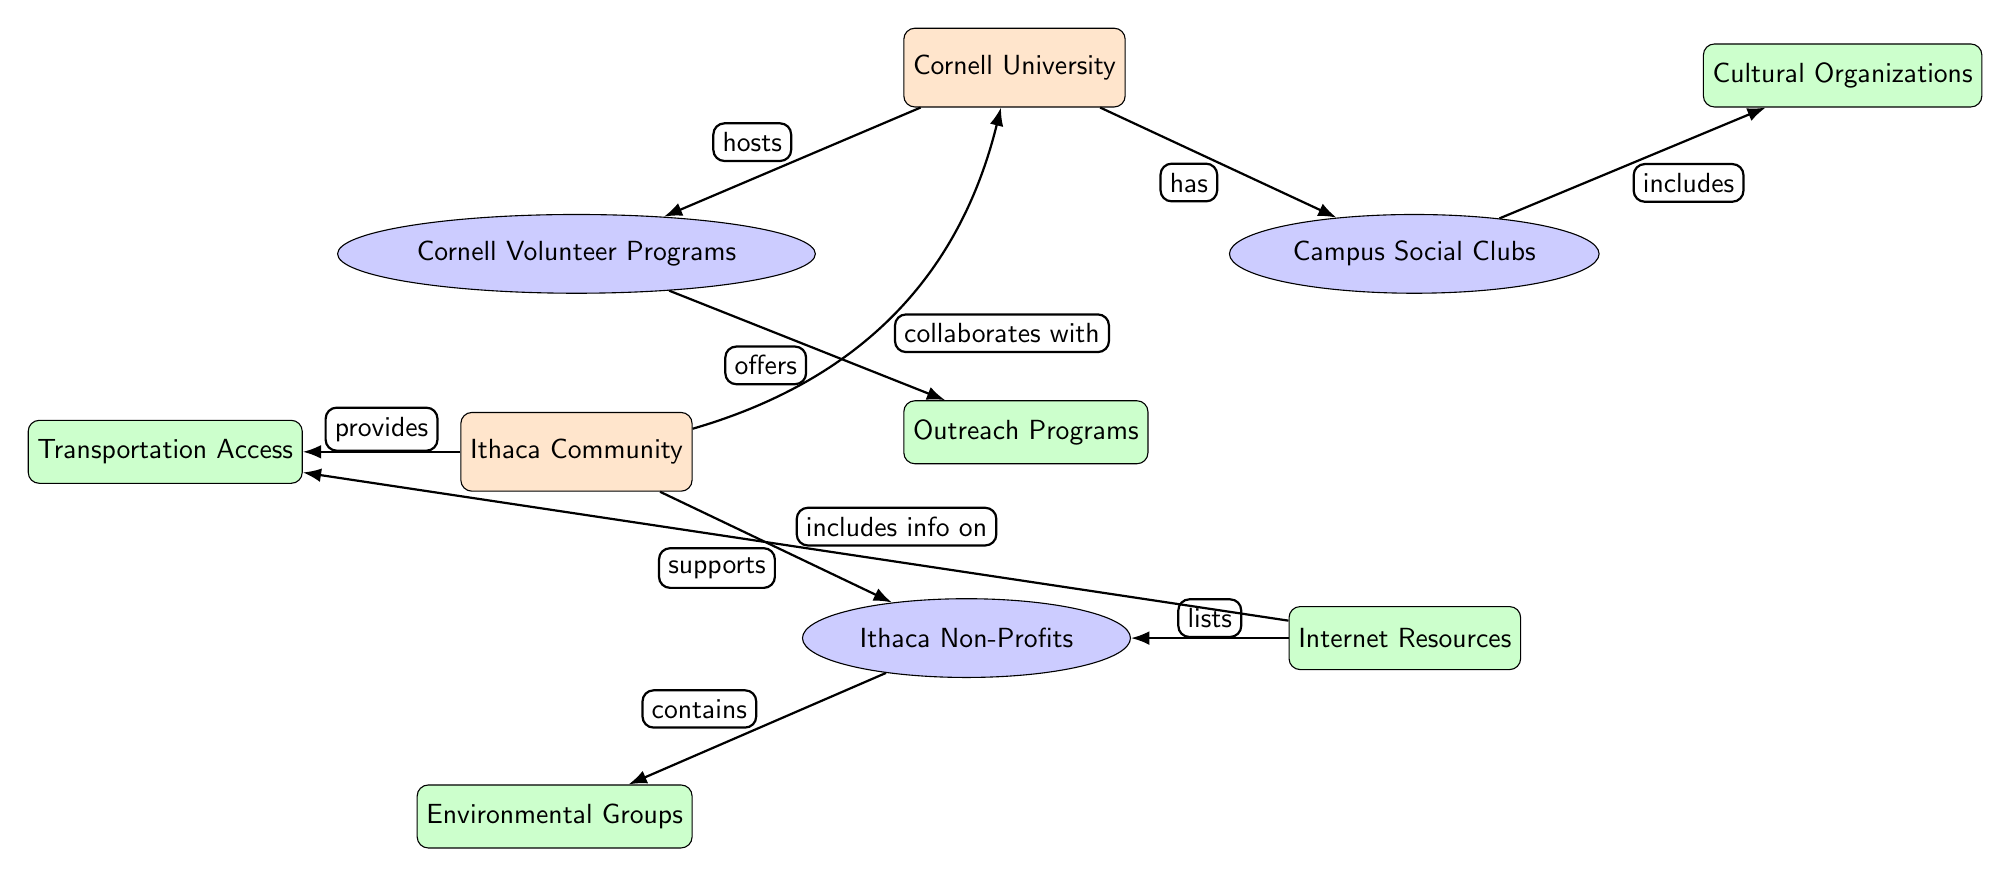What's the main node in the diagram? The main node is labeled "Cornell University," which appears at the top of the diagram and represents the central entity related to social clubs and volunteering organizations in Ithaca.
Answer: Cornell University How many secondary nodes are there? There are four secondary nodes in the diagram, as identified by the ellipses surrounding "Cornell Volunteer Programs," "Campus Social Clubs," and "Ithaca Non-Profits."
Answer: 4 What relationship exists between Cornell University and Campus Social Clubs? The relationship is described as "has" indicating that Cornell University provides or facilitates the existence of Campus Social Clubs.
Answer: has Which node provides information on transportation access? The node labeled "Transportation Access" indicates the resource related to accessing various locations and activities in Ithaca.
Answer: Transportation Access What type of organizations are included in the Ithaca Non-Profits node? The diagram indicates that "Environmental Groups" are nested within the Ithaca Non-Profits node, showing the type of organizations available.
Answer: Environmental Groups How do Campus Social Clubs and Cultural Organizations connect? The connection is established through the edge indicating that Campus Social Clubs "includes" Cultural Organizations as part of their scope of activities.
Answer: includes What supports the Ithaca Community's collaboration with Cornell University? The Ithaca Community node has a connecting edge labeled "collaborates with" which identifies the relationship supporting interactions with Cornell University.
Answer: collaborates with Which node is both a secondary and tertiary type in the diagram? The "Ithaca Non-Profits" node is a secondary node, while "Environmental Groups" is a tertiary node, showcasing categories within the community organizations.
Answer: None How many edges are connected to the Ithaca Community node? The Ithaca Community node is connected to three edges leading to the Ithaca Non-Profits, Transportation Access, and collaborating with Cornell University, indicating multiple relationships.
Answer: 3 